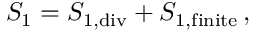Convert formula to latex. <formula><loc_0><loc_0><loc_500><loc_500>S _ { 1 } = S _ { 1 , d i v } + S _ { 1 , f i n i t e } \, ,</formula> 